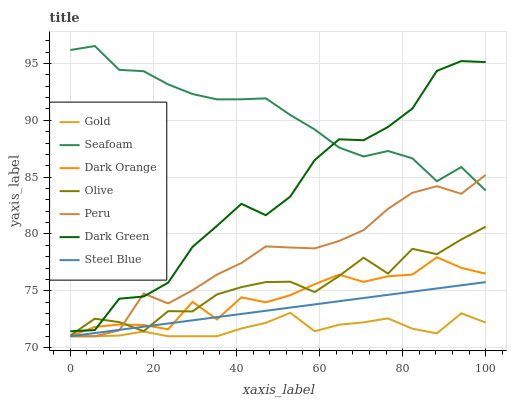Does Gold have the minimum area under the curve?
Answer yes or no. Yes. Does Seafoam have the maximum area under the curve?
Answer yes or no. Yes. Does Seafoam have the minimum area under the curve?
Answer yes or no. No. Does Gold have the maximum area under the curve?
Answer yes or no. No. Is Steel Blue the smoothest?
Answer yes or no. Yes. Is Dark Green the roughest?
Answer yes or no. Yes. Is Gold the smoothest?
Answer yes or no. No. Is Gold the roughest?
Answer yes or no. No. Does Seafoam have the lowest value?
Answer yes or no. No. Does Seafoam have the highest value?
Answer yes or no. Yes. Does Gold have the highest value?
Answer yes or no. No. Is Gold less than Seafoam?
Answer yes or no. Yes. Is Seafoam greater than Dark Orange?
Answer yes or no. Yes. Does Gold intersect Seafoam?
Answer yes or no. No. 